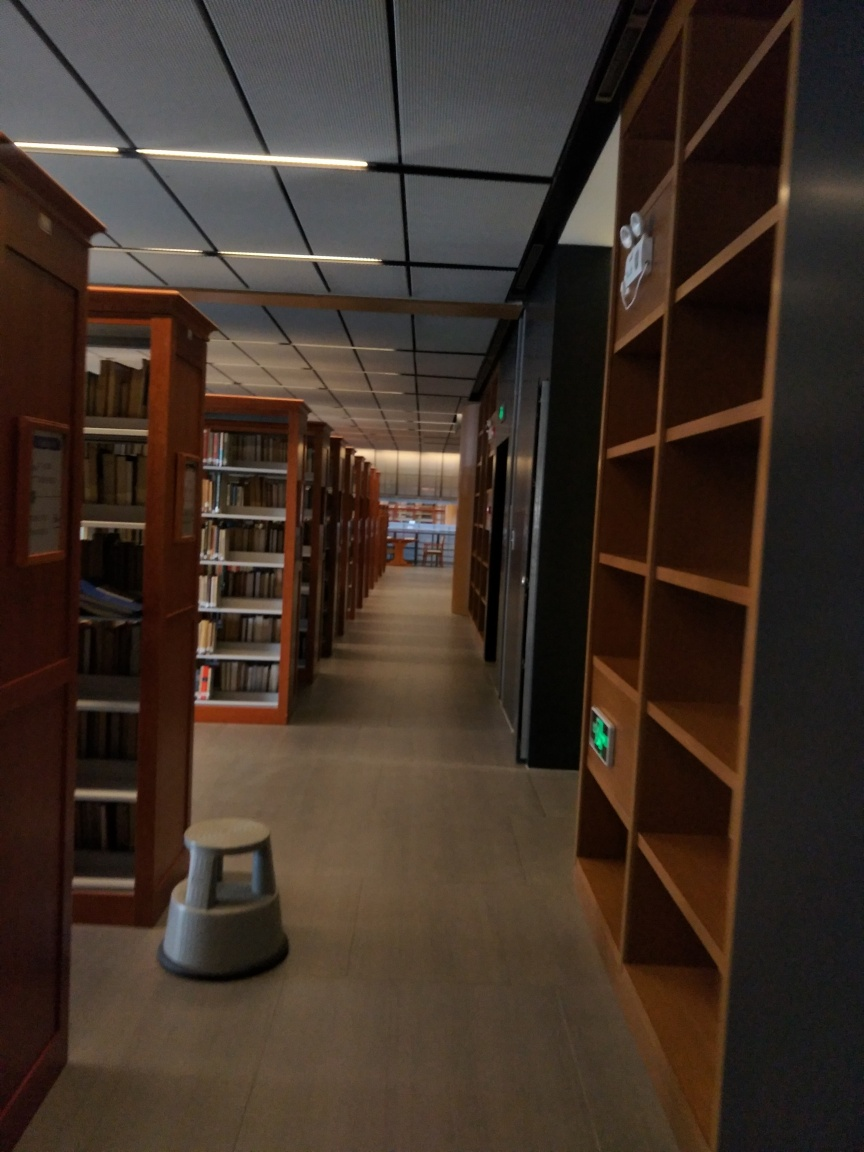Is there noticeable noise in the image?
A. Silent
B. No
C. Yes.
D. Minimal
Answer with the option's letter from the given choices directly. Based on the visual quality of the image, the closest answer would be 'D. Minimal.' The image appears to have some graininess, particularly in the darker areas, suggesting a low level of noise that doesn't significantly detract from the overall clarity. 